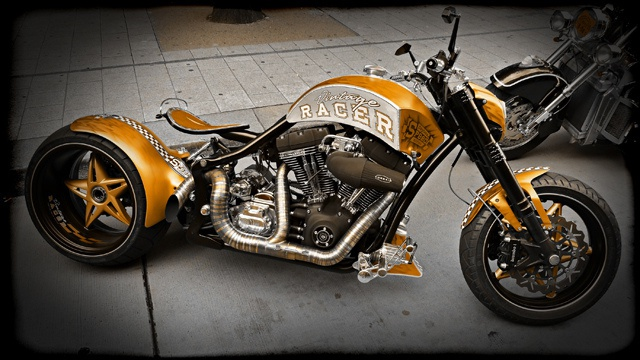Describe the objects in this image and their specific colors. I can see motorcycle in black, gray, darkgray, and brown tones and motorcycle in black, gray, and darkgray tones in this image. 